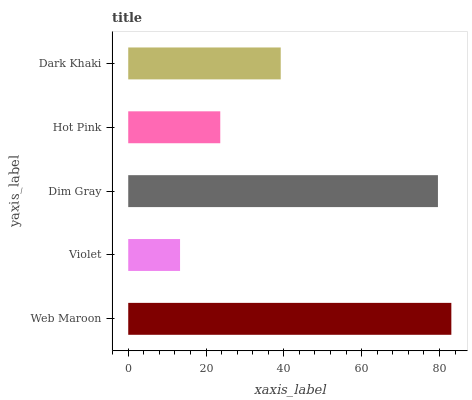Is Violet the minimum?
Answer yes or no. Yes. Is Web Maroon the maximum?
Answer yes or no. Yes. Is Dim Gray the minimum?
Answer yes or no. No. Is Dim Gray the maximum?
Answer yes or no. No. Is Dim Gray greater than Violet?
Answer yes or no. Yes. Is Violet less than Dim Gray?
Answer yes or no. Yes. Is Violet greater than Dim Gray?
Answer yes or no. No. Is Dim Gray less than Violet?
Answer yes or no. No. Is Dark Khaki the high median?
Answer yes or no. Yes. Is Dark Khaki the low median?
Answer yes or no. Yes. Is Violet the high median?
Answer yes or no. No. Is Web Maroon the low median?
Answer yes or no. No. 